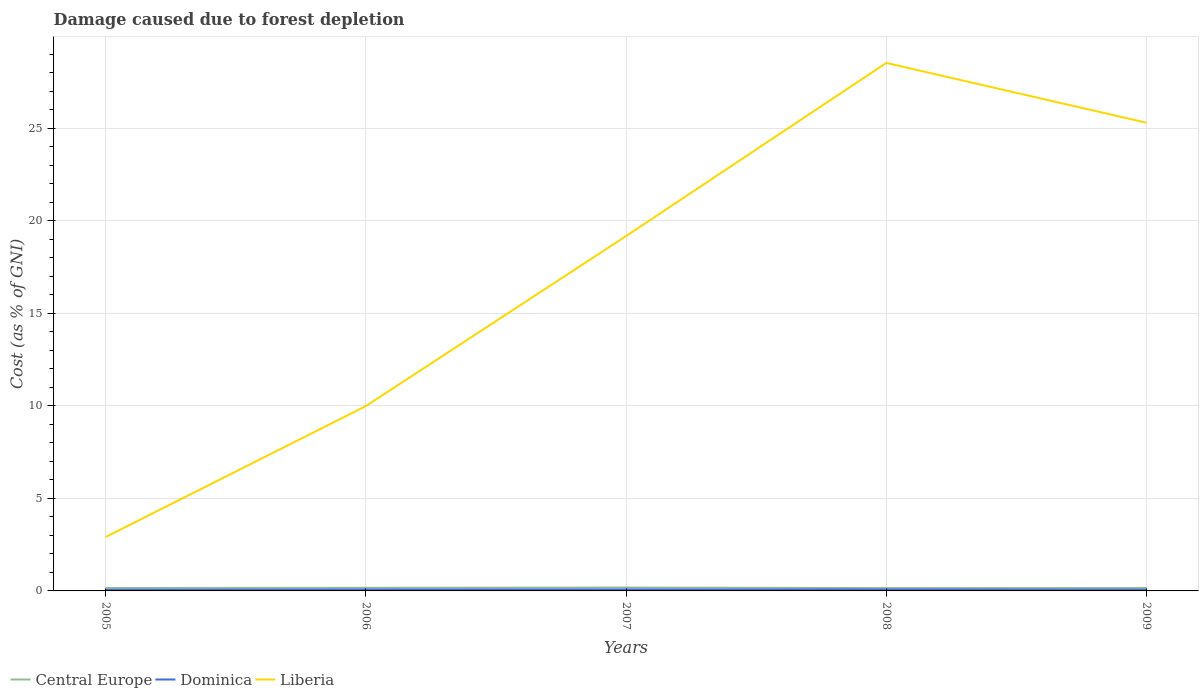How many different coloured lines are there?
Keep it short and to the point. 3. Across all years, what is the maximum cost of damage caused due to forest depletion in Liberia?
Offer a terse response. 2.91. In which year was the cost of damage caused due to forest depletion in Central Europe maximum?
Offer a very short reply. 2008. What is the total cost of damage caused due to forest depletion in Dominica in the graph?
Ensure brevity in your answer.  0.01. What is the difference between the highest and the second highest cost of damage caused due to forest depletion in Liberia?
Make the answer very short. 25.61. What is the difference between the highest and the lowest cost of damage caused due to forest depletion in Liberia?
Keep it short and to the point. 3. How many years are there in the graph?
Give a very brief answer. 5. What is the difference between two consecutive major ticks on the Y-axis?
Make the answer very short. 5. Does the graph contain any zero values?
Keep it short and to the point. No. Where does the legend appear in the graph?
Provide a succinct answer. Bottom left. How are the legend labels stacked?
Provide a short and direct response. Horizontal. What is the title of the graph?
Give a very brief answer. Damage caused due to forest depletion. Does "Central African Republic" appear as one of the legend labels in the graph?
Provide a succinct answer. No. What is the label or title of the Y-axis?
Your answer should be very brief. Cost (as % of GNI). What is the Cost (as % of GNI) of Central Europe in 2005?
Offer a terse response. 0.16. What is the Cost (as % of GNI) of Dominica in 2005?
Keep it short and to the point. 0.06. What is the Cost (as % of GNI) in Liberia in 2005?
Give a very brief answer. 2.91. What is the Cost (as % of GNI) of Central Europe in 2006?
Offer a terse response. 0.17. What is the Cost (as % of GNI) of Dominica in 2006?
Your answer should be very brief. 0.07. What is the Cost (as % of GNI) in Liberia in 2006?
Offer a very short reply. 9.99. What is the Cost (as % of GNI) in Central Europe in 2007?
Give a very brief answer. 0.18. What is the Cost (as % of GNI) in Dominica in 2007?
Ensure brevity in your answer.  0.08. What is the Cost (as % of GNI) in Liberia in 2007?
Your answer should be compact. 19.17. What is the Cost (as % of GNI) in Central Europe in 2008?
Provide a succinct answer. 0.15. What is the Cost (as % of GNI) in Dominica in 2008?
Offer a terse response. 0.07. What is the Cost (as % of GNI) in Liberia in 2008?
Your response must be concise. 28.52. What is the Cost (as % of GNI) of Central Europe in 2009?
Your answer should be very brief. 0.16. What is the Cost (as % of GNI) in Dominica in 2009?
Offer a terse response. 0.06. What is the Cost (as % of GNI) of Liberia in 2009?
Keep it short and to the point. 25.29. Across all years, what is the maximum Cost (as % of GNI) in Central Europe?
Keep it short and to the point. 0.18. Across all years, what is the maximum Cost (as % of GNI) in Dominica?
Offer a terse response. 0.08. Across all years, what is the maximum Cost (as % of GNI) in Liberia?
Your response must be concise. 28.52. Across all years, what is the minimum Cost (as % of GNI) in Central Europe?
Your answer should be compact. 0.15. Across all years, what is the minimum Cost (as % of GNI) of Dominica?
Offer a very short reply. 0.06. Across all years, what is the minimum Cost (as % of GNI) in Liberia?
Ensure brevity in your answer.  2.91. What is the total Cost (as % of GNI) of Central Europe in the graph?
Your answer should be compact. 0.82. What is the total Cost (as % of GNI) in Dominica in the graph?
Make the answer very short. 0.35. What is the total Cost (as % of GNI) in Liberia in the graph?
Give a very brief answer. 85.89. What is the difference between the Cost (as % of GNI) of Central Europe in 2005 and that in 2006?
Ensure brevity in your answer.  -0.01. What is the difference between the Cost (as % of GNI) of Dominica in 2005 and that in 2006?
Keep it short and to the point. -0.02. What is the difference between the Cost (as % of GNI) in Liberia in 2005 and that in 2006?
Ensure brevity in your answer.  -7.07. What is the difference between the Cost (as % of GNI) in Central Europe in 2005 and that in 2007?
Offer a very short reply. -0.03. What is the difference between the Cost (as % of GNI) of Dominica in 2005 and that in 2007?
Your answer should be very brief. -0.02. What is the difference between the Cost (as % of GNI) of Liberia in 2005 and that in 2007?
Provide a succinct answer. -16.26. What is the difference between the Cost (as % of GNI) of Central Europe in 2005 and that in 2008?
Ensure brevity in your answer.  0. What is the difference between the Cost (as % of GNI) of Dominica in 2005 and that in 2008?
Your answer should be compact. -0.02. What is the difference between the Cost (as % of GNI) of Liberia in 2005 and that in 2008?
Give a very brief answer. -25.61. What is the difference between the Cost (as % of GNI) in Central Europe in 2005 and that in 2009?
Offer a very short reply. -0. What is the difference between the Cost (as % of GNI) in Dominica in 2005 and that in 2009?
Ensure brevity in your answer.  -0.01. What is the difference between the Cost (as % of GNI) in Liberia in 2005 and that in 2009?
Ensure brevity in your answer.  -22.38. What is the difference between the Cost (as % of GNI) of Central Europe in 2006 and that in 2007?
Your answer should be compact. -0.01. What is the difference between the Cost (as % of GNI) of Dominica in 2006 and that in 2007?
Your answer should be compact. -0. What is the difference between the Cost (as % of GNI) of Liberia in 2006 and that in 2007?
Give a very brief answer. -9.18. What is the difference between the Cost (as % of GNI) in Central Europe in 2006 and that in 2008?
Your answer should be compact. 0.02. What is the difference between the Cost (as % of GNI) in Dominica in 2006 and that in 2008?
Ensure brevity in your answer.  -0. What is the difference between the Cost (as % of GNI) in Liberia in 2006 and that in 2008?
Your response must be concise. -18.53. What is the difference between the Cost (as % of GNI) in Central Europe in 2006 and that in 2009?
Give a very brief answer. 0.01. What is the difference between the Cost (as % of GNI) in Dominica in 2006 and that in 2009?
Your response must be concise. 0.01. What is the difference between the Cost (as % of GNI) in Liberia in 2006 and that in 2009?
Provide a succinct answer. -15.3. What is the difference between the Cost (as % of GNI) in Central Europe in 2007 and that in 2008?
Ensure brevity in your answer.  0.03. What is the difference between the Cost (as % of GNI) of Dominica in 2007 and that in 2008?
Keep it short and to the point. 0. What is the difference between the Cost (as % of GNI) of Liberia in 2007 and that in 2008?
Offer a terse response. -9.35. What is the difference between the Cost (as % of GNI) of Central Europe in 2007 and that in 2009?
Keep it short and to the point. 0.02. What is the difference between the Cost (as % of GNI) of Dominica in 2007 and that in 2009?
Your response must be concise. 0.02. What is the difference between the Cost (as % of GNI) in Liberia in 2007 and that in 2009?
Make the answer very short. -6.12. What is the difference between the Cost (as % of GNI) in Central Europe in 2008 and that in 2009?
Your answer should be very brief. -0.01. What is the difference between the Cost (as % of GNI) of Dominica in 2008 and that in 2009?
Your answer should be very brief. 0.01. What is the difference between the Cost (as % of GNI) in Liberia in 2008 and that in 2009?
Make the answer very short. 3.23. What is the difference between the Cost (as % of GNI) of Central Europe in 2005 and the Cost (as % of GNI) of Dominica in 2006?
Give a very brief answer. 0.08. What is the difference between the Cost (as % of GNI) in Central Europe in 2005 and the Cost (as % of GNI) in Liberia in 2006?
Give a very brief answer. -9.83. What is the difference between the Cost (as % of GNI) of Dominica in 2005 and the Cost (as % of GNI) of Liberia in 2006?
Ensure brevity in your answer.  -9.93. What is the difference between the Cost (as % of GNI) of Central Europe in 2005 and the Cost (as % of GNI) of Dominica in 2007?
Ensure brevity in your answer.  0.08. What is the difference between the Cost (as % of GNI) of Central Europe in 2005 and the Cost (as % of GNI) of Liberia in 2007?
Your response must be concise. -19.01. What is the difference between the Cost (as % of GNI) in Dominica in 2005 and the Cost (as % of GNI) in Liberia in 2007?
Ensure brevity in your answer.  -19.11. What is the difference between the Cost (as % of GNI) in Central Europe in 2005 and the Cost (as % of GNI) in Dominica in 2008?
Offer a terse response. 0.08. What is the difference between the Cost (as % of GNI) in Central Europe in 2005 and the Cost (as % of GNI) in Liberia in 2008?
Give a very brief answer. -28.37. What is the difference between the Cost (as % of GNI) in Dominica in 2005 and the Cost (as % of GNI) in Liberia in 2008?
Make the answer very short. -28.47. What is the difference between the Cost (as % of GNI) in Central Europe in 2005 and the Cost (as % of GNI) in Dominica in 2009?
Give a very brief answer. 0.09. What is the difference between the Cost (as % of GNI) of Central Europe in 2005 and the Cost (as % of GNI) of Liberia in 2009?
Ensure brevity in your answer.  -25.13. What is the difference between the Cost (as % of GNI) in Dominica in 2005 and the Cost (as % of GNI) in Liberia in 2009?
Provide a short and direct response. -25.24. What is the difference between the Cost (as % of GNI) of Central Europe in 2006 and the Cost (as % of GNI) of Dominica in 2007?
Provide a short and direct response. 0.09. What is the difference between the Cost (as % of GNI) in Central Europe in 2006 and the Cost (as % of GNI) in Liberia in 2007?
Your answer should be compact. -19. What is the difference between the Cost (as % of GNI) of Dominica in 2006 and the Cost (as % of GNI) of Liberia in 2007?
Keep it short and to the point. -19.1. What is the difference between the Cost (as % of GNI) of Central Europe in 2006 and the Cost (as % of GNI) of Dominica in 2008?
Provide a short and direct response. 0.09. What is the difference between the Cost (as % of GNI) in Central Europe in 2006 and the Cost (as % of GNI) in Liberia in 2008?
Keep it short and to the point. -28.35. What is the difference between the Cost (as % of GNI) of Dominica in 2006 and the Cost (as % of GNI) of Liberia in 2008?
Make the answer very short. -28.45. What is the difference between the Cost (as % of GNI) in Central Europe in 2006 and the Cost (as % of GNI) in Dominica in 2009?
Give a very brief answer. 0.11. What is the difference between the Cost (as % of GNI) in Central Europe in 2006 and the Cost (as % of GNI) in Liberia in 2009?
Your response must be concise. -25.12. What is the difference between the Cost (as % of GNI) in Dominica in 2006 and the Cost (as % of GNI) in Liberia in 2009?
Make the answer very short. -25.22. What is the difference between the Cost (as % of GNI) in Central Europe in 2007 and the Cost (as % of GNI) in Dominica in 2008?
Offer a terse response. 0.11. What is the difference between the Cost (as % of GNI) of Central Europe in 2007 and the Cost (as % of GNI) of Liberia in 2008?
Your answer should be very brief. -28.34. What is the difference between the Cost (as % of GNI) of Dominica in 2007 and the Cost (as % of GNI) of Liberia in 2008?
Give a very brief answer. -28.44. What is the difference between the Cost (as % of GNI) of Central Europe in 2007 and the Cost (as % of GNI) of Dominica in 2009?
Provide a short and direct response. 0.12. What is the difference between the Cost (as % of GNI) in Central Europe in 2007 and the Cost (as % of GNI) in Liberia in 2009?
Make the answer very short. -25.11. What is the difference between the Cost (as % of GNI) in Dominica in 2007 and the Cost (as % of GNI) in Liberia in 2009?
Provide a succinct answer. -25.21. What is the difference between the Cost (as % of GNI) in Central Europe in 2008 and the Cost (as % of GNI) in Dominica in 2009?
Your answer should be compact. 0.09. What is the difference between the Cost (as % of GNI) in Central Europe in 2008 and the Cost (as % of GNI) in Liberia in 2009?
Your answer should be very brief. -25.14. What is the difference between the Cost (as % of GNI) in Dominica in 2008 and the Cost (as % of GNI) in Liberia in 2009?
Make the answer very short. -25.22. What is the average Cost (as % of GNI) of Central Europe per year?
Offer a terse response. 0.16. What is the average Cost (as % of GNI) of Dominica per year?
Ensure brevity in your answer.  0.07. What is the average Cost (as % of GNI) in Liberia per year?
Offer a terse response. 17.18. In the year 2005, what is the difference between the Cost (as % of GNI) in Central Europe and Cost (as % of GNI) in Dominica?
Offer a very short reply. 0.1. In the year 2005, what is the difference between the Cost (as % of GNI) in Central Europe and Cost (as % of GNI) in Liberia?
Give a very brief answer. -2.76. In the year 2005, what is the difference between the Cost (as % of GNI) in Dominica and Cost (as % of GNI) in Liberia?
Keep it short and to the point. -2.86. In the year 2006, what is the difference between the Cost (as % of GNI) in Central Europe and Cost (as % of GNI) in Dominica?
Offer a terse response. 0.09. In the year 2006, what is the difference between the Cost (as % of GNI) of Central Europe and Cost (as % of GNI) of Liberia?
Give a very brief answer. -9.82. In the year 2006, what is the difference between the Cost (as % of GNI) in Dominica and Cost (as % of GNI) in Liberia?
Your answer should be very brief. -9.91. In the year 2007, what is the difference between the Cost (as % of GNI) in Central Europe and Cost (as % of GNI) in Dominica?
Your answer should be very brief. 0.1. In the year 2007, what is the difference between the Cost (as % of GNI) of Central Europe and Cost (as % of GNI) of Liberia?
Your response must be concise. -18.99. In the year 2007, what is the difference between the Cost (as % of GNI) of Dominica and Cost (as % of GNI) of Liberia?
Offer a terse response. -19.09. In the year 2008, what is the difference between the Cost (as % of GNI) in Central Europe and Cost (as % of GNI) in Dominica?
Offer a terse response. 0.08. In the year 2008, what is the difference between the Cost (as % of GNI) of Central Europe and Cost (as % of GNI) of Liberia?
Ensure brevity in your answer.  -28.37. In the year 2008, what is the difference between the Cost (as % of GNI) in Dominica and Cost (as % of GNI) in Liberia?
Keep it short and to the point. -28.45. In the year 2009, what is the difference between the Cost (as % of GNI) of Central Europe and Cost (as % of GNI) of Dominica?
Keep it short and to the point. 0.1. In the year 2009, what is the difference between the Cost (as % of GNI) of Central Europe and Cost (as % of GNI) of Liberia?
Your answer should be compact. -25.13. In the year 2009, what is the difference between the Cost (as % of GNI) of Dominica and Cost (as % of GNI) of Liberia?
Your response must be concise. -25.23. What is the ratio of the Cost (as % of GNI) of Central Europe in 2005 to that in 2006?
Provide a short and direct response. 0.93. What is the ratio of the Cost (as % of GNI) in Dominica in 2005 to that in 2006?
Provide a short and direct response. 0.76. What is the ratio of the Cost (as % of GNI) of Liberia in 2005 to that in 2006?
Keep it short and to the point. 0.29. What is the ratio of the Cost (as % of GNI) in Central Europe in 2005 to that in 2007?
Offer a very short reply. 0.86. What is the ratio of the Cost (as % of GNI) of Dominica in 2005 to that in 2007?
Offer a very short reply. 0.72. What is the ratio of the Cost (as % of GNI) of Liberia in 2005 to that in 2007?
Your answer should be compact. 0.15. What is the ratio of the Cost (as % of GNI) in Central Europe in 2005 to that in 2008?
Keep it short and to the point. 1.02. What is the ratio of the Cost (as % of GNI) of Dominica in 2005 to that in 2008?
Ensure brevity in your answer.  0.75. What is the ratio of the Cost (as % of GNI) in Liberia in 2005 to that in 2008?
Provide a succinct answer. 0.1. What is the ratio of the Cost (as % of GNI) in Dominica in 2005 to that in 2009?
Offer a terse response. 0.9. What is the ratio of the Cost (as % of GNI) in Liberia in 2005 to that in 2009?
Your response must be concise. 0.12. What is the ratio of the Cost (as % of GNI) in Central Europe in 2006 to that in 2007?
Provide a short and direct response. 0.92. What is the ratio of the Cost (as % of GNI) in Dominica in 2006 to that in 2007?
Your answer should be compact. 0.95. What is the ratio of the Cost (as % of GNI) of Liberia in 2006 to that in 2007?
Ensure brevity in your answer.  0.52. What is the ratio of the Cost (as % of GNI) of Central Europe in 2006 to that in 2008?
Give a very brief answer. 1.1. What is the ratio of the Cost (as % of GNI) of Dominica in 2006 to that in 2008?
Ensure brevity in your answer.  0.99. What is the ratio of the Cost (as % of GNI) in Liberia in 2006 to that in 2008?
Provide a short and direct response. 0.35. What is the ratio of the Cost (as % of GNI) of Central Europe in 2006 to that in 2009?
Offer a very short reply. 1.06. What is the ratio of the Cost (as % of GNI) of Dominica in 2006 to that in 2009?
Your answer should be compact. 1.18. What is the ratio of the Cost (as % of GNI) in Liberia in 2006 to that in 2009?
Offer a very short reply. 0.39. What is the ratio of the Cost (as % of GNI) in Central Europe in 2007 to that in 2008?
Make the answer very short. 1.19. What is the ratio of the Cost (as % of GNI) in Dominica in 2007 to that in 2008?
Offer a terse response. 1.05. What is the ratio of the Cost (as % of GNI) of Liberia in 2007 to that in 2008?
Your answer should be very brief. 0.67. What is the ratio of the Cost (as % of GNI) of Central Europe in 2007 to that in 2009?
Your answer should be very brief. 1.15. What is the ratio of the Cost (as % of GNI) of Dominica in 2007 to that in 2009?
Your response must be concise. 1.25. What is the ratio of the Cost (as % of GNI) of Liberia in 2007 to that in 2009?
Make the answer very short. 0.76. What is the ratio of the Cost (as % of GNI) in Dominica in 2008 to that in 2009?
Offer a terse response. 1.19. What is the ratio of the Cost (as % of GNI) in Liberia in 2008 to that in 2009?
Your response must be concise. 1.13. What is the difference between the highest and the second highest Cost (as % of GNI) of Central Europe?
Provide a short and direct response. 0.01. What is the difference between the highest and the second highest Cost (as % of GNI) in Dominica?
Give a very brief answer. 0. What is the difference between the highest and the second highest Cost (as % of GNI) of Liberia?
Your answer should be compact. 3.23. What is the difference between the highest and the lowest Cost (as % of GNI) of Central Europe?
Ensure brevity in your answer.  0.03. What is the difference between the highest and the lowest Cost (as % of GNI) of Dominica?
Provide a succinct answer. 0.02. What is the difference between the highest and the lowest Cost (as % of GNI) of Liberia?
Your answer should be very brief. 25.61. 